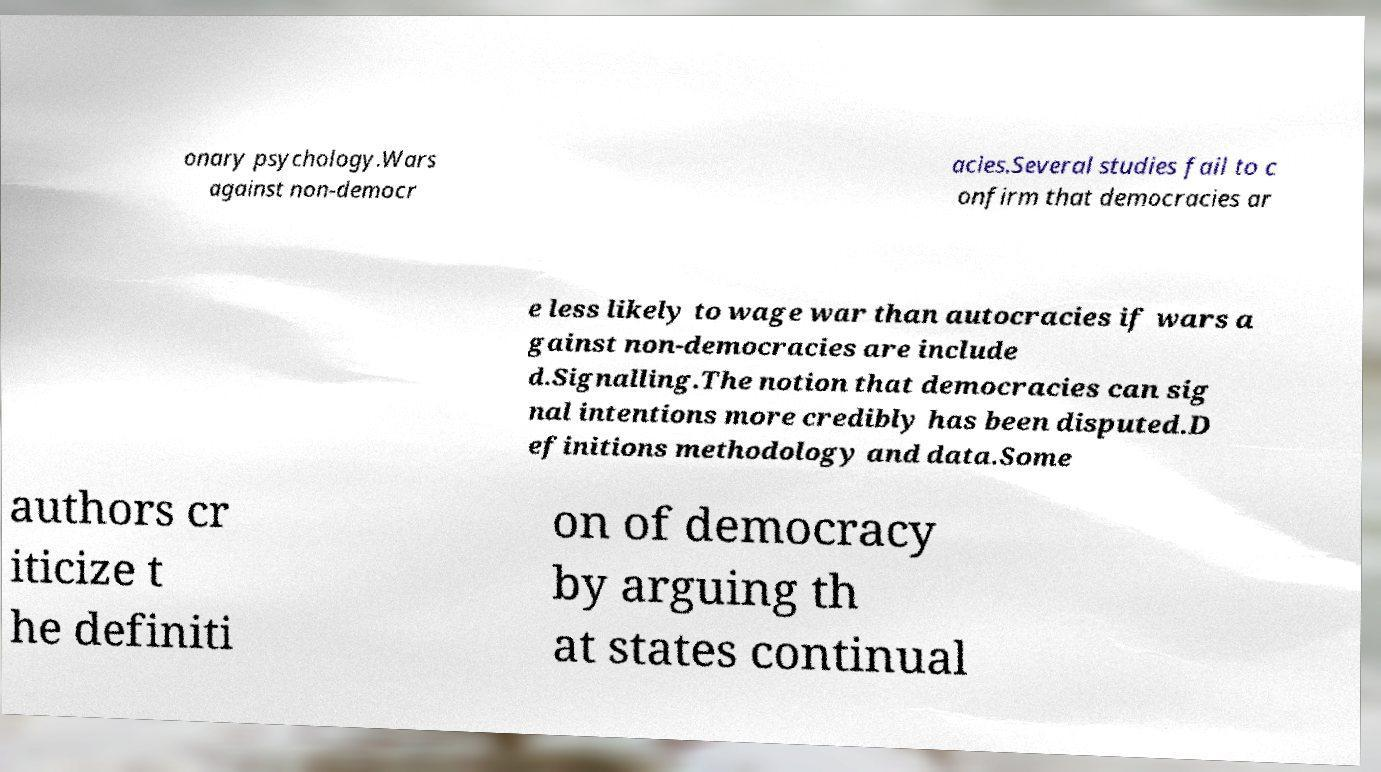Could you assist in decoding the text presented in this image and type it out clearly? onary psychology.Wars against non-democr acies.Several studies fail to c onfirm that democracies ar e less likely to wage war than autocracies if wars a gainst non-democracies are include d.Signalling.The notion that democracies can sig nal intentions more credibly has been disputed.D efinitions methodology and data.Some authors cr iticize t he definiti on of democracy by arguing th at states continual 